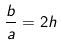Convert formula to latex. <formula><loc_0><loc_0><loc_500><loc_500>\frac { b } { a } = 2 h</formula> 